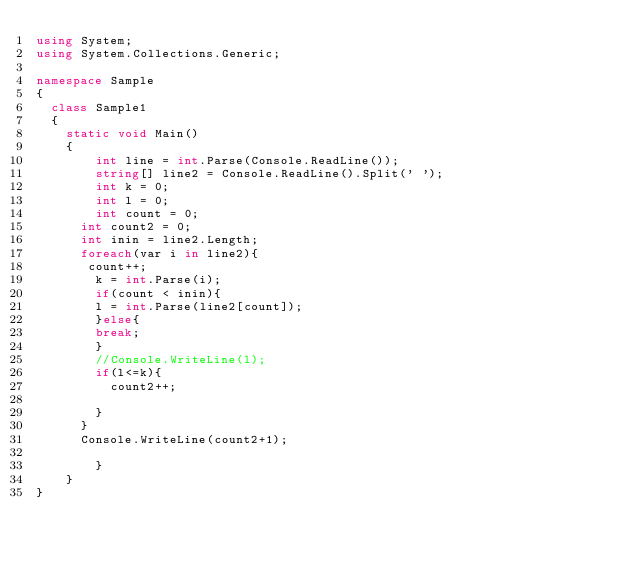<code> <loc_0><loc_0><loc_500><loc_500><_C#_>using System;
using System.Collections.Generic;
 
namespace Sample
{
  class Sample1
  {
    static void Main()
    {
		int line = int.Parse(Console.ReadLine());
      	string[] line2 = Console.ReadLine().Split(' ');
  		int k = 0;	
        int l = 0;	
		int count = 0;
      int count2 = 0;
      int inin = line2.Length;
      foreach(var i in line2){
       count++;
        k = int.Parse(i);
        if(count < inin){
        l = int.Parse(line2[count]);
        }else{
        break;
        }
        //Console.WriteLine(l);
        if(l<=k){
          count2++;
        
        }
      }
      Console.WriteLine(count2+1);
            
		}
	}
}</code> 